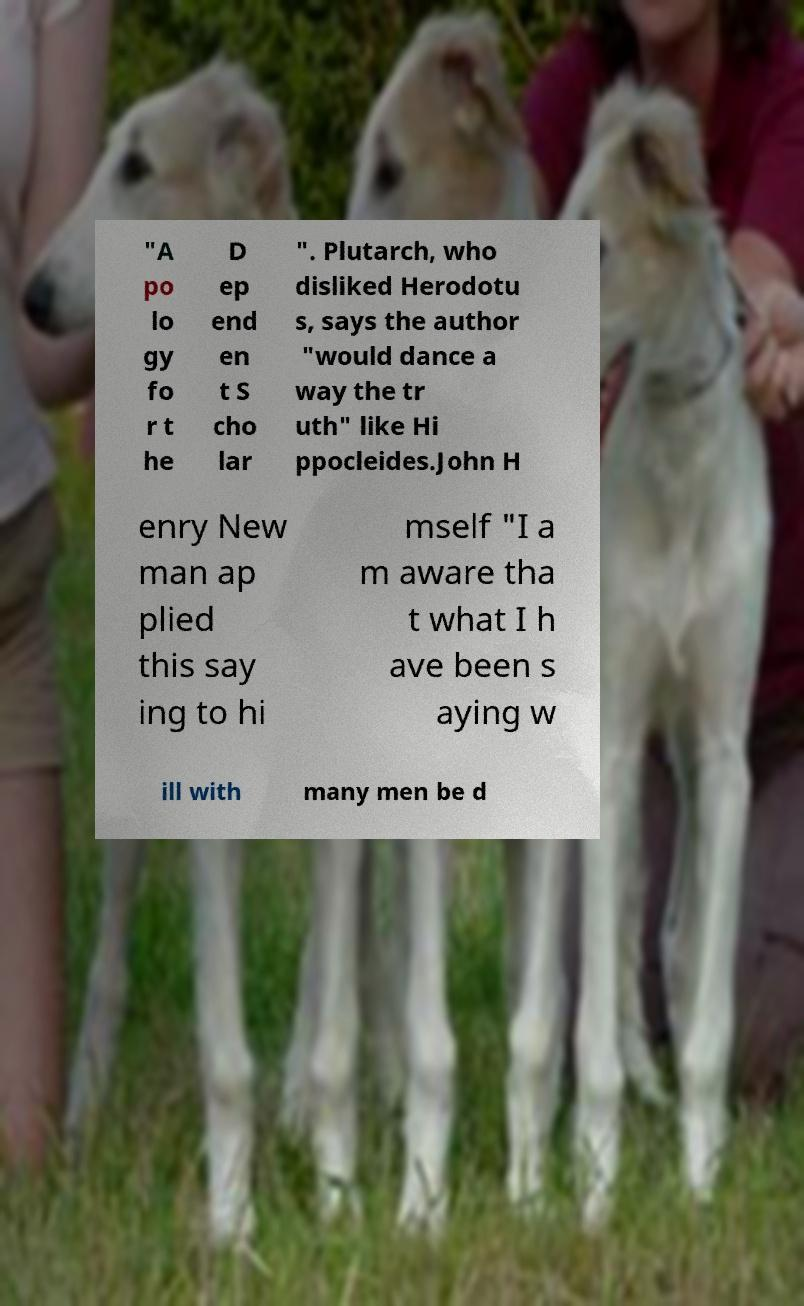Could you extract and type out the text from this image? "A po lo gy fo r t he D ep end en t S cho lar ". Plutarch, who disliked Herodotu s, says the author "would dance a way the tr uth" like Hi ppocleides.John H enry New man ap plied this say ing to hi mself "I a m aware tha t what I h ave been s aying w ill with many men be d 